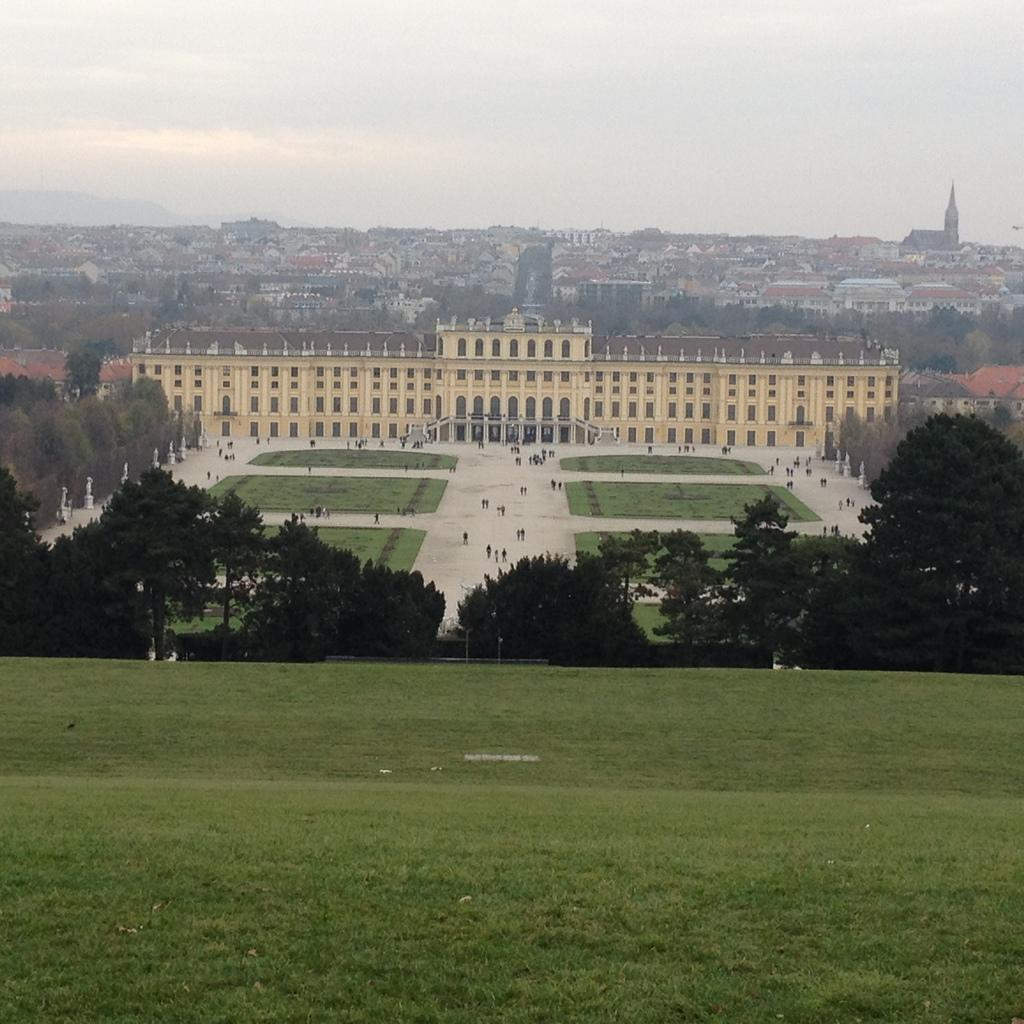What type of structures can be seen in the image? There are buildings in the image. What natural elements are present in the image? There are trees and green grass in the image. Are there any living beings in the image? Yes, there are people in the image. How would you describe the color of the sky in the image? The sky is in white and blue color in the image. Can you tell me how many chances the bean has to win the squirrel's game in the image? There is no bean or squirrel's game present in the image, so it is not possible to determine the number of chances. 